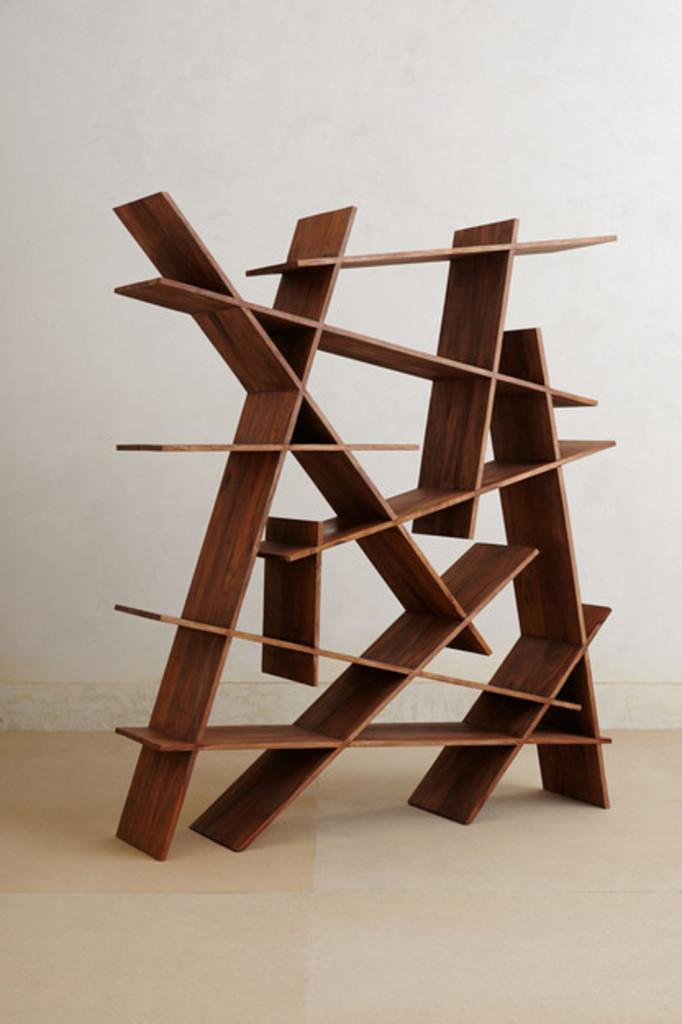What type of structure is present in the image? There is a wooden rack in the image. What color is the wall behind the wooden rack? There is a white wall in the image. What surface can be seen beneath the wooden rack? There is a floor visible in the image. What type of popcorn is being served on the wooden rack in the image? There is no popcorn present in the image; it only features a wooden rack and a white wall. 